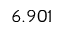Convert formula to latex. <formula><loc_0><loc_0><loc_500><loc_500>6 . 9 0 1</formula> 